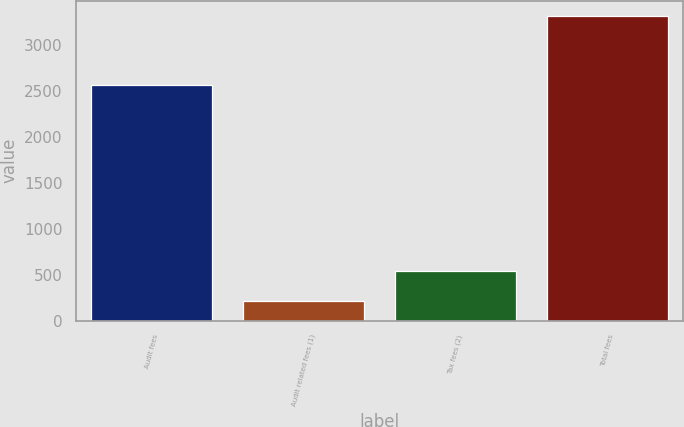Convert chart. <chart><loc_0><loc_0><loc_500><loc_500><bar_chart><fcel>Audit fees<fcel>Audit related fees (1)<fcel>Tax fees (2)<fcel>Total fees<nl><fcel>2558<fcel>215<fcel>537<fcel>3310<nl></chart> 